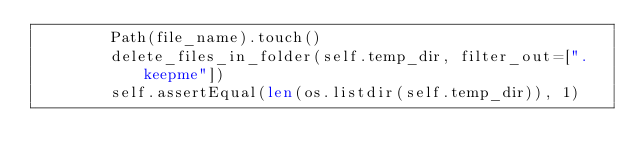Convert code to text. <code><loc_0><loc_0><loc_500><loc_500><_Python_>        Path(file_name).touch()
        delete_files_in_folder(self.temp_dir, filter_out=[".keepme"])
        self.assertEqual(len(os.listdir(self.temp_dir)), 1)
</code> 